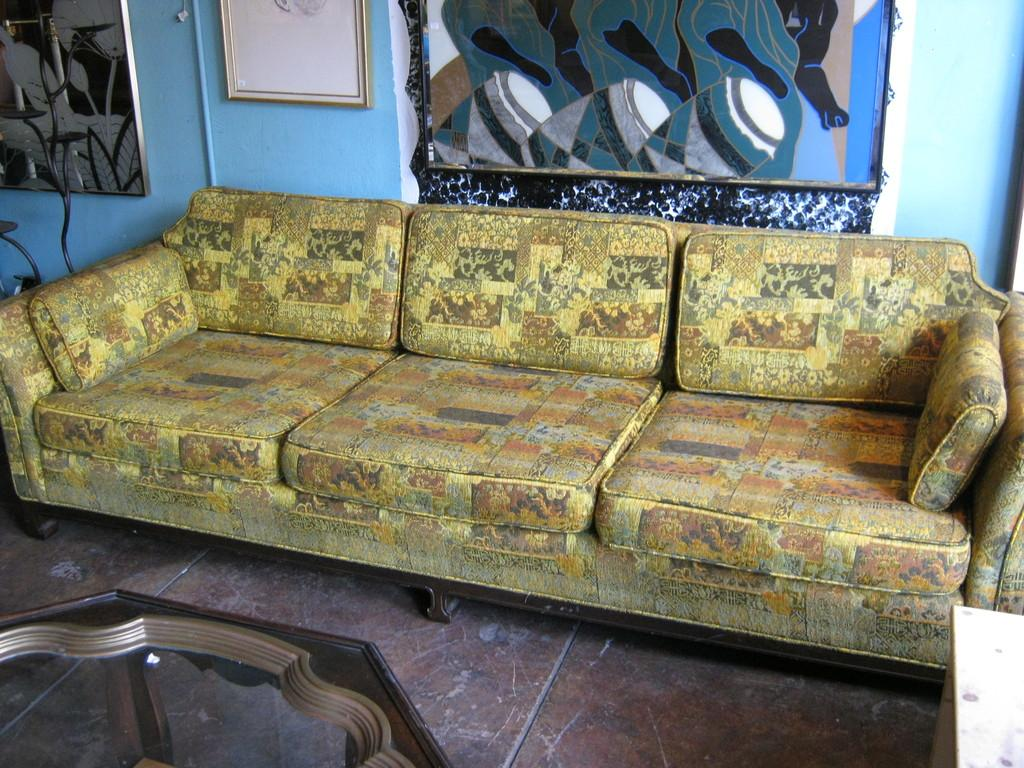What type of surface is visible in the image? There is a floor in the image. What piece of furniture can be seen in the image? There is a table in the image. What colorful piece of furniture is present in the image? The couch in the image is yellow, brown, black, and orange in color. What color is the wall in the image? The wall in the image is blue. What is attached to the wall in the image? There are frames attached to the wall in the image. What advice does the committee give about the soda in the image? There is no committee or soda present in the image, so no advice can be given. 